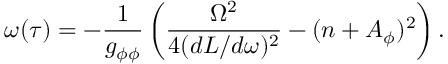Convert formula to latex. <formula><loc_0><loc_0><loc_500><loc_500>\omega ( \tau ) = - \frac { 1 } { g _ { \phi \phi } } \left ( \frac { \Omega ^ { 2 } } { 4 ( d L / d \omega ) ^ { 2 } } - ( n + A _ { \phi } ) ^ { 2 } \right ) .</formula> 